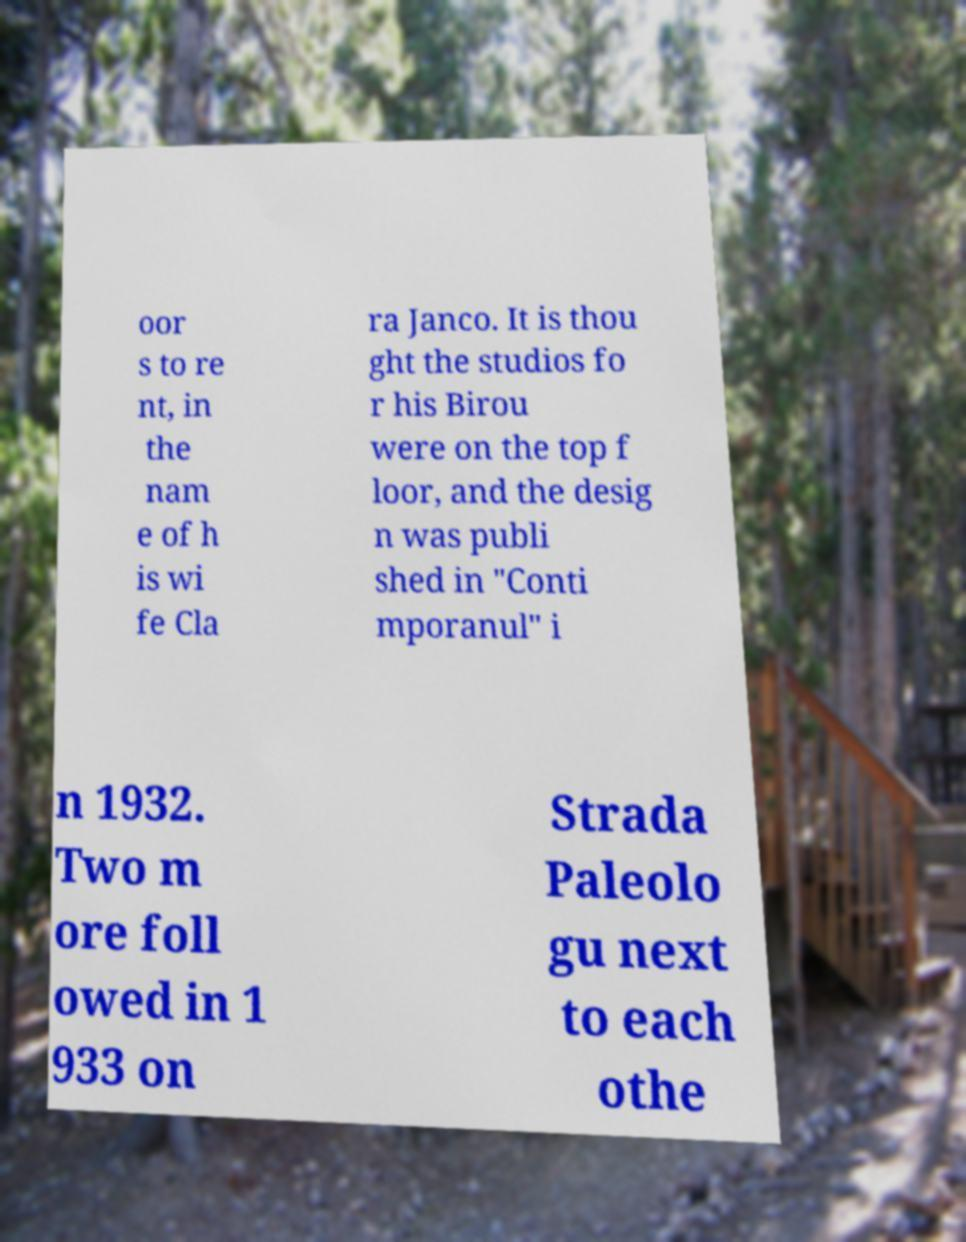Could you extract and type out the text from this image? oor s to re nt, in the nam e of h is wi fe Cla ra Janco. It is thou ght the studios fo r his Birou were on the top f loor, and the desig n was publi shed in "Conti mporanul" i n 1932. Two m ore foll owed in 1 933 on Strada Paleolo gu next to each othe 